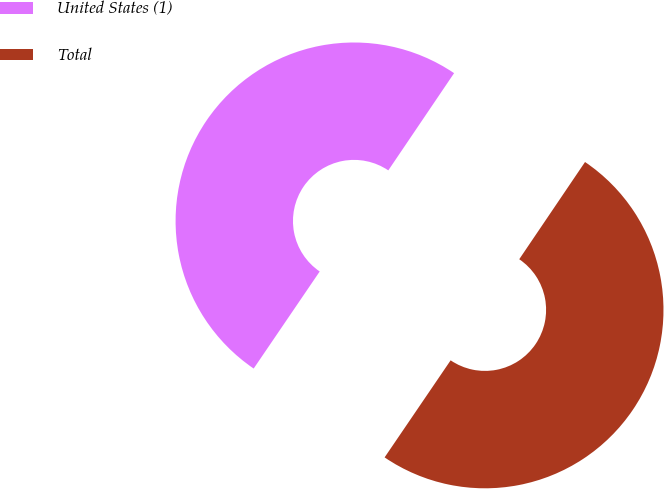Convert chart to OTSL. <chart><loc_0><loc_0><loc_500><loc_500><pie_chart><fcel>United States (1)<fcel>Total<nl><fcel>49.96%<fcel>50.04%<nl></chart> 